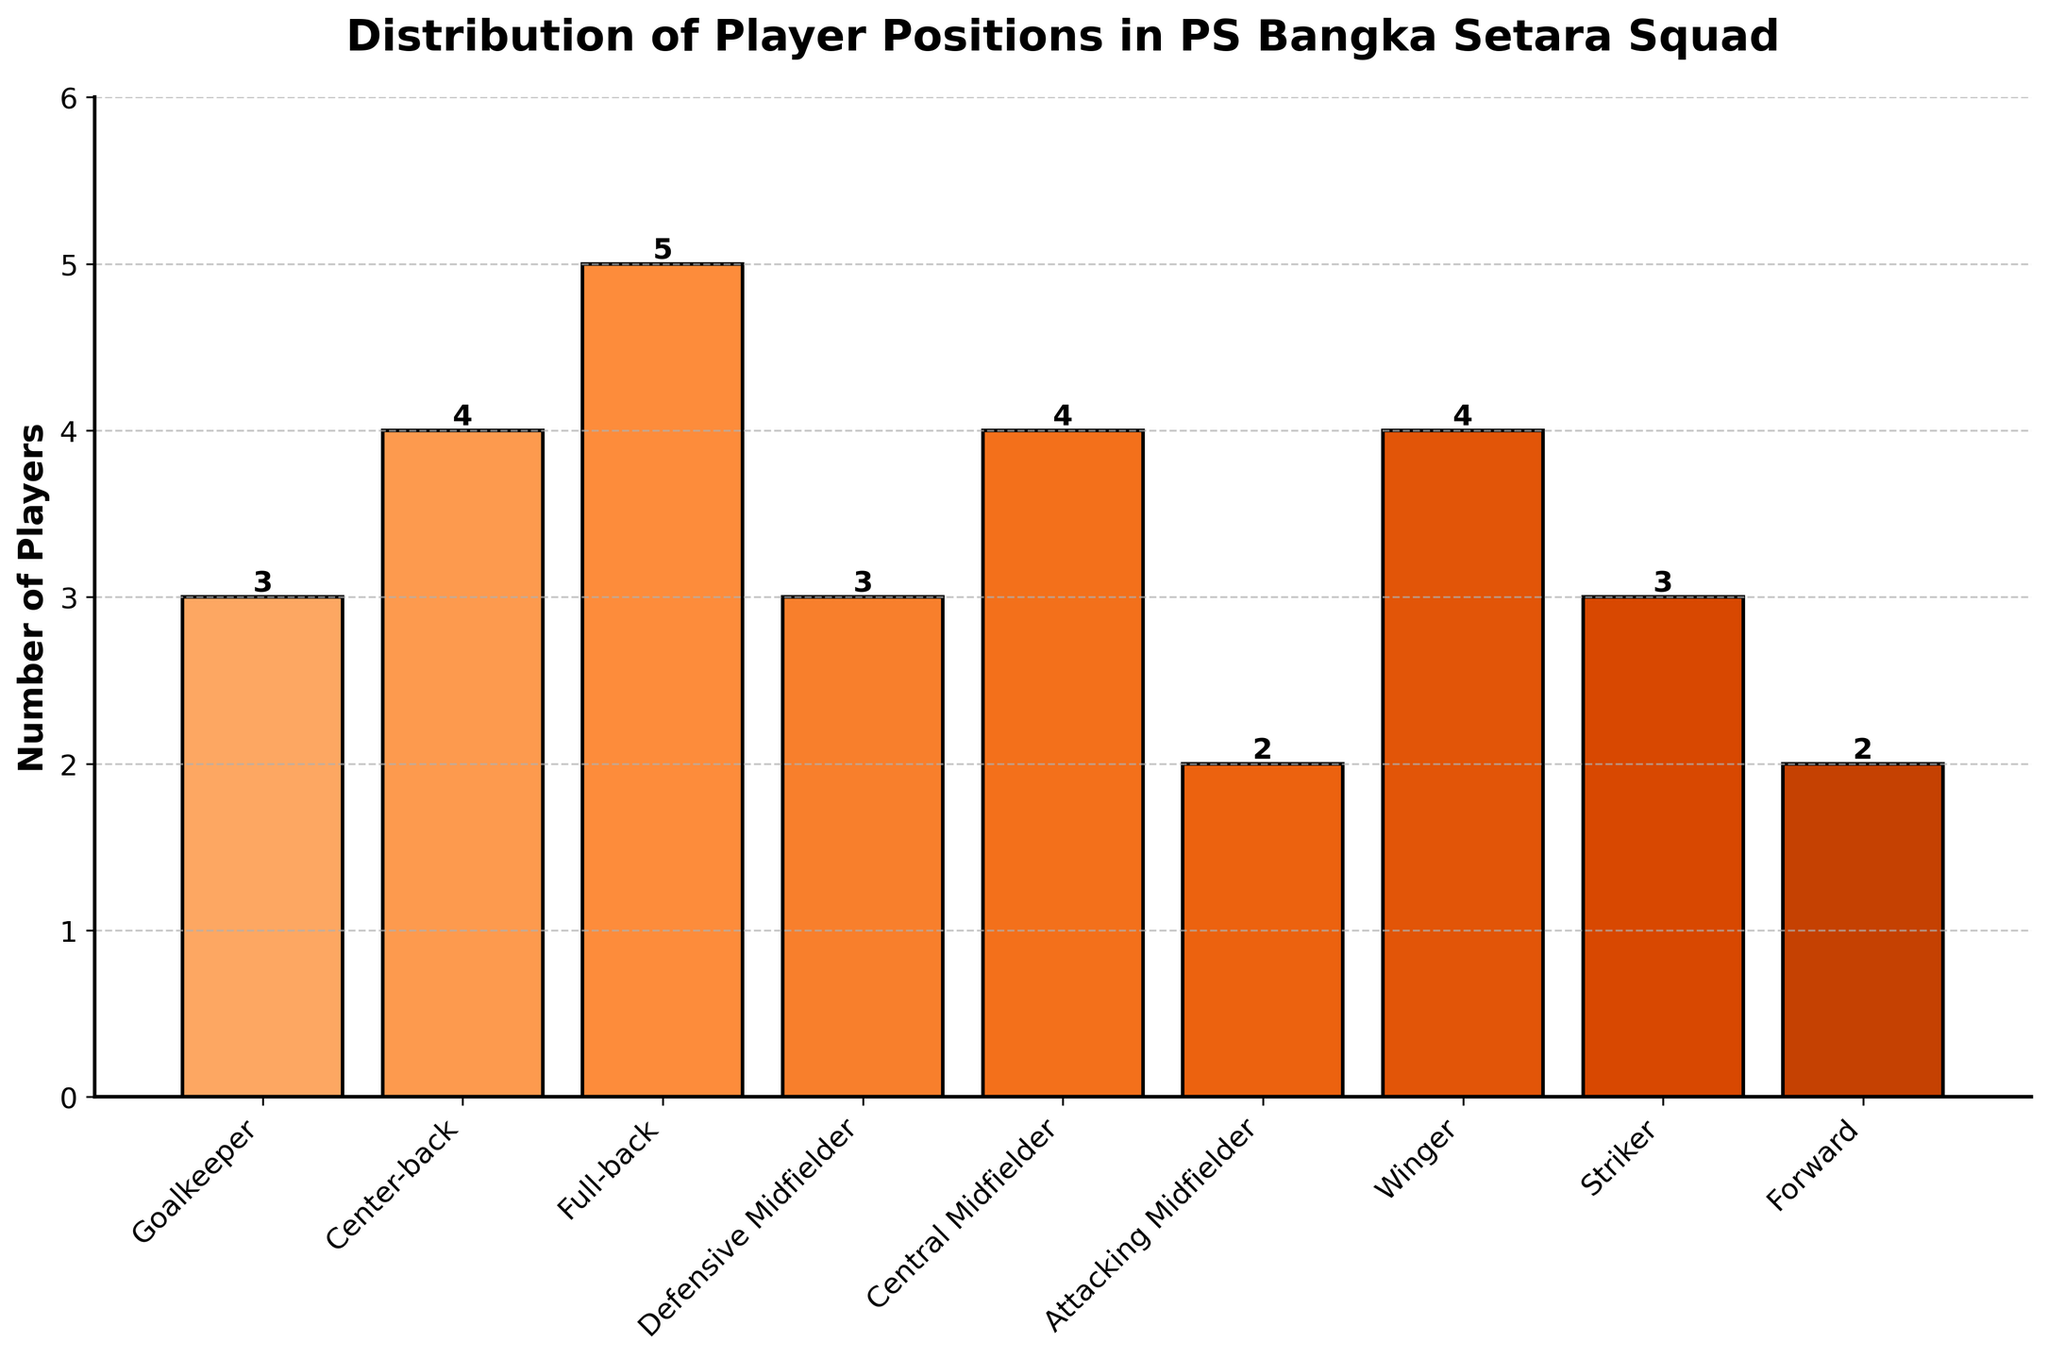Which position has the most players in the PS Bangka Setara squad? By looking at the heights of the bars in the chart, the Full-back position has the highest bar, indicating it has the most players.
Answer: Full-back How many total midfielders (defensive, central, and attacking) are there? Add the number of players in all midfielder positions: Defensive Midfielder has 3, Central Midfielder has 4, and Attacking Midfielder has 2. So, 3 + 4 + 2 = 9.
Answer: 9 Are there more Wingers or Forwards in the squad? Compare the heights of the bars for Wingers and Forwards: Wingers have 4 players and Forwards have 2 players.
Answer: Wingers Is the number of Center-backs greater than or equal to the number of Goalkeepers and Strikers combined? Add the number of players in Goalkeeper and Striker positions: 3 (Goalkeepers) + 3 (Strikers) = 6. Compare this with the number of Center-backs, which is 4.
Answer: No Which position has the fewest players? Check the height of each bar to find the shortest one. Attacking Midfielder and Forward both have the shortest bars with 2 players each.
Answer: Attacking Midfielder and Forward How many more Full-backs are there than Goalkeepers? The number of Full-backs is 5 and the number of Goalkeepers is 3. Subtract the number of Goalkeepers from Full-backs: 5 - 3 = 2.
Answer: 2 What is the average number of players per position? Sum all the players from each position and then divide by the number of positions. The total number of players is 3+4+5+3+4+2+4+3+2 = 30. There are 9 positions. So, the average is 30/9 ≈ 3.33.
Answer: 3.33 Which positions have exactly 3 players? Identify the bars with a height of 3. Goalkeeper, Defensive Midfielder, and Striker each have 3 players.
Answer: Goalkeeper, Defensive Midfielder, and Striker How many players are in the attacking positions (Attacking Midfielder, Winger, Striker, Forward)? Add the number of players in Attacking Midfielder (2), Winger (4), Striker (3), and Forward (2). So, 2 + 4 + 3 + 2 = 11.
Answer: 11 